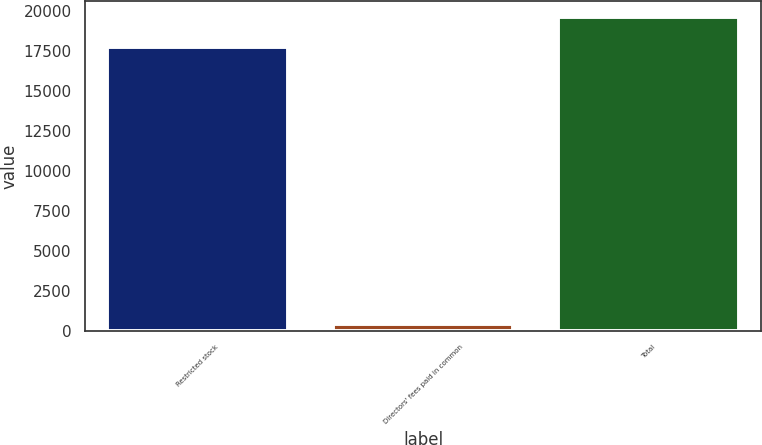Convert chart. <chart><loc_0><loc_0><loc_500><loc_500><bar_chart><fcel>Restricted stock<fcel>Directors' fees paid in common<fcel>Total<nl><fcel>17725<fcel>389<fcel>19599.9<nl></chart> 